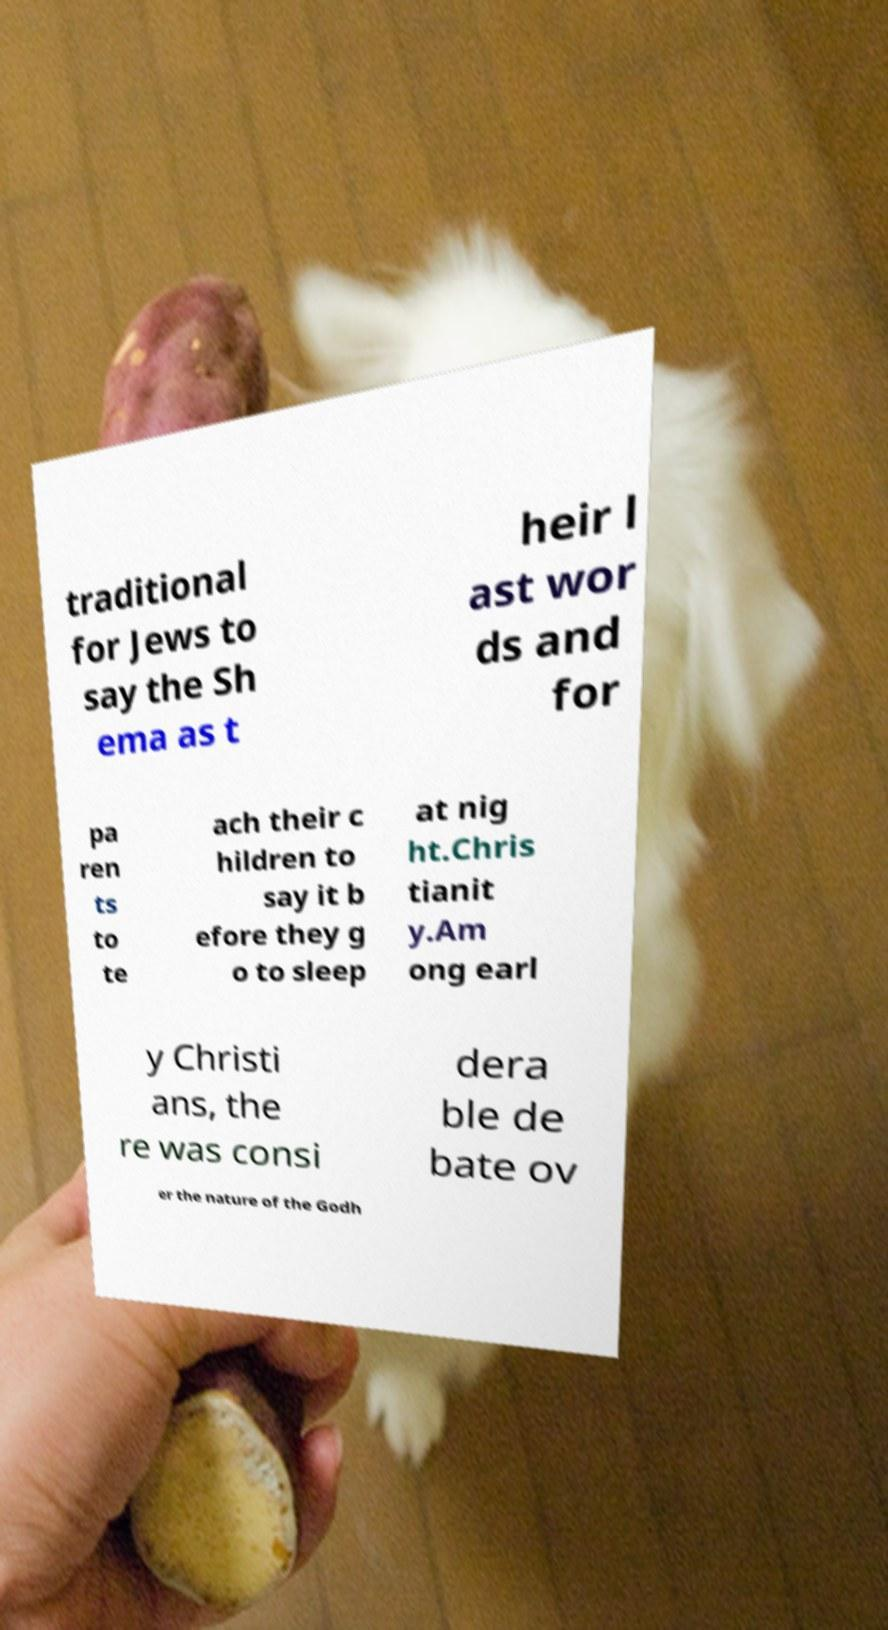There's text embedded in this image that I need extracted. Can you transcribe it verbatim? traditional for Jews to say the Sh ema as t heir l ast wor ds and for pa ren ts to te ach their c hildren to say it b efore they g o to sleep at nig ht.Chris tianit y.Am ong earl y Christi ans, the re was consi dera ble de bate ov er the nature of the Godh 